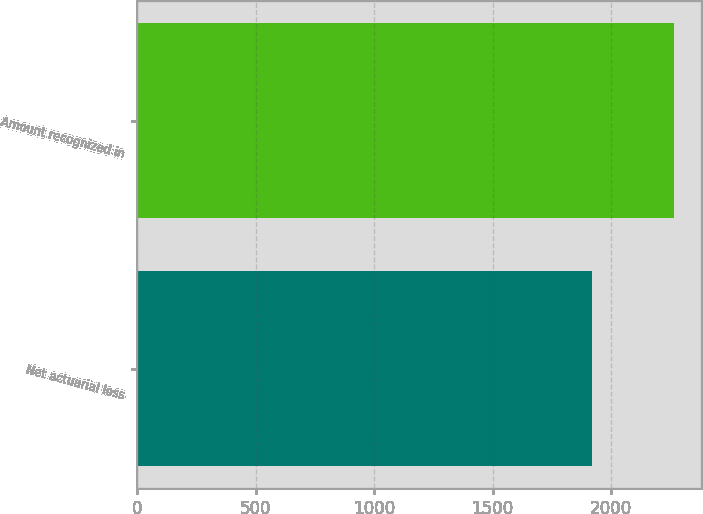<chart> <loc_0><loc_0><loc_500><loc_500><bar_chart><fcel>Net actuarial loss<fcel>Amount recognized in<nl><fcel>1921<fcel>2267<nl></chart> 